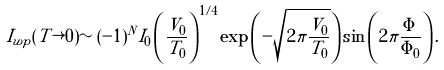Convert formula to latex. <formula><loc_0><loc_0><loc_500><loc_500>I _ { w p } ( T \rightarrow 0 ) \sim ( - 1 ) ^ { N } I _ { 0 } \left ( \frac { V _ { 0 } } { T _ { 0 } } \right ) ^ { 1 / 4 } \exp \left ( - \sqrt { 2 \pi \frac { V _ { 0 } } { T _ { 0 } } } \right ) \sin \left ( 2 \pi \frac { \Phi } { \Phi _ { 0 } } \right ) .</formula> 